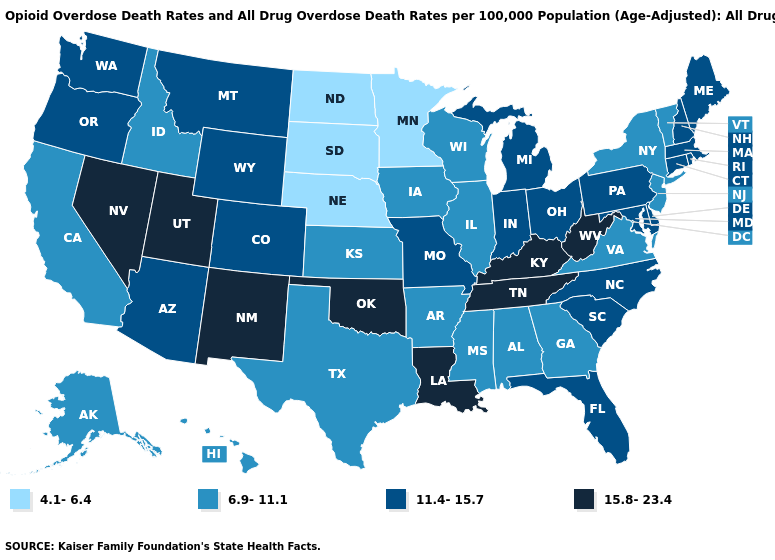What is the value of North Dakota?
Concise answer only. 4.1-6.4. Among the states that border Texas , which have the highest value?
Concise answer only. Louisiana, New Mexico, Oklahoma. Does Mississippi have the lowest value in the USA?
Quick response, please. No. What is the value of California?
Keep it brief. 6.9-11.1. Name the states that have a value in the range 15.8-23.4?
Concise answer only. Kentucky, Louisiana, Nevada, New Mexico, Oklahoma, Tennessee, Utah, West Virginia. What is the value of Oregon?
Quick response, please. 11.4-15.7. What is the value of Kentucky?
Be succinct. 15.8-23.4. What is the lowest value in states that border Kentucky?
Concise answer only. 6.9-11.1. Name the states that have a value in the range 4.1-6.4?
Keep it brief. Minnesota, Nebraska, North Dakota, South Dakota. What is the value of Georgia?
Short answer required. 6.9-11.1. Among the states that border Montana , does South Dakota have the lowest value?
Answer briefly. Yes. Among the states that border Missouri , does Oklahoma have the highest value?
Keep it brief. Yes. Does the first symbol in the legend represent the smallest category?
Concise answer only. Yes. What is the value of South Dakota?
Quick response, please. 4.1-6.4. Among the states that border New York , does Massachusetts have the highest value?
Concise answer only. Yes. 